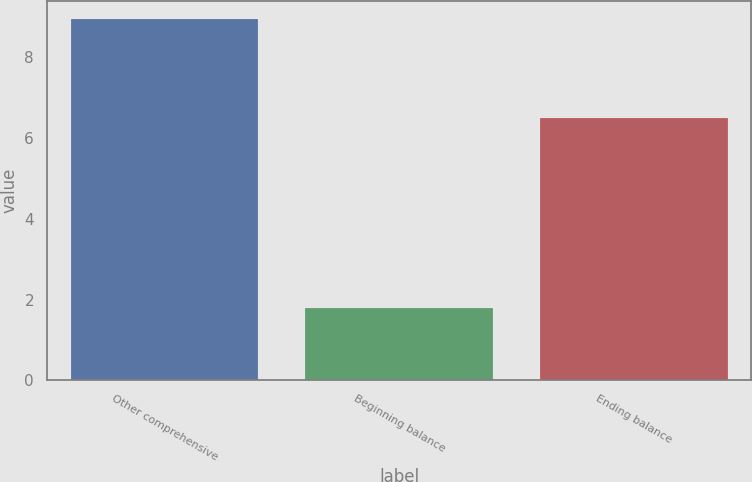<chart> <loc_0><loc_0><loc_500><loc_500><bar_chart><fcel>Other comprehensive<fcel>Beginning balance<fcel>Ending balance<nl><fcel>8.95<fcel>1.8<fcel>6.5<nl></chart> 